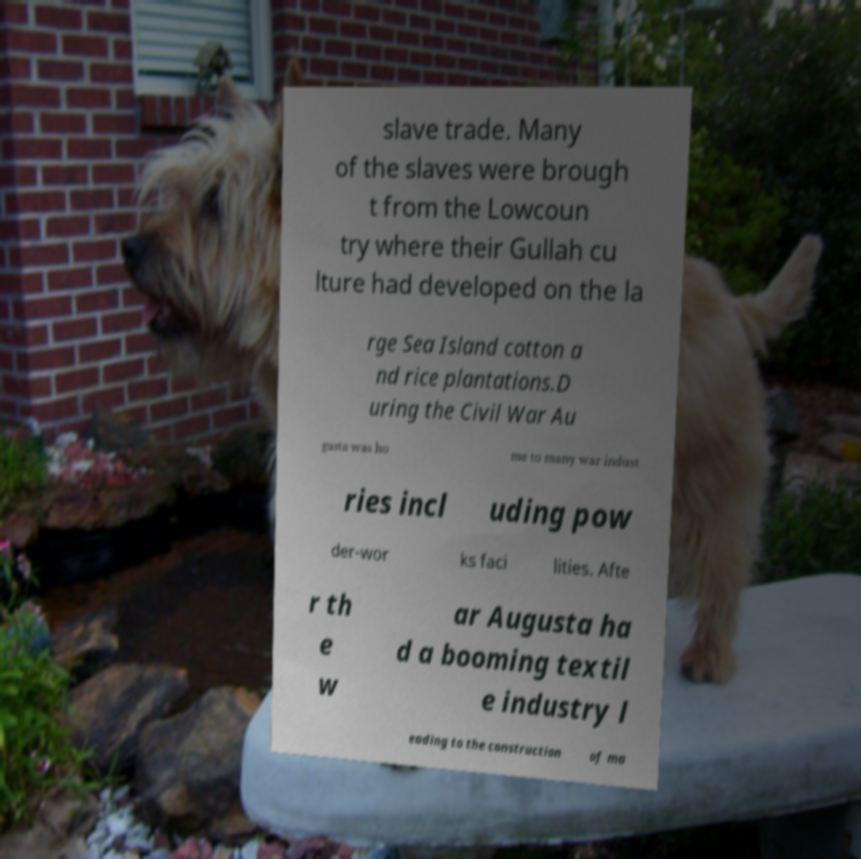For documentation purposes, I need the text within this image transcribed. Could you provide that? slave trade. Many of the slaves were brough t from the Lowcoun try where their Gullah cu lture had developed on the la rge Sea Island cotton a nd rice plantations.D uring the Civil War Au gusta was ho me to many war indust ries incl uding pow der-wor ks faci lities. Afte r th e w ar Augusta ha d a booming textil e industry l eading to the construction of ma 